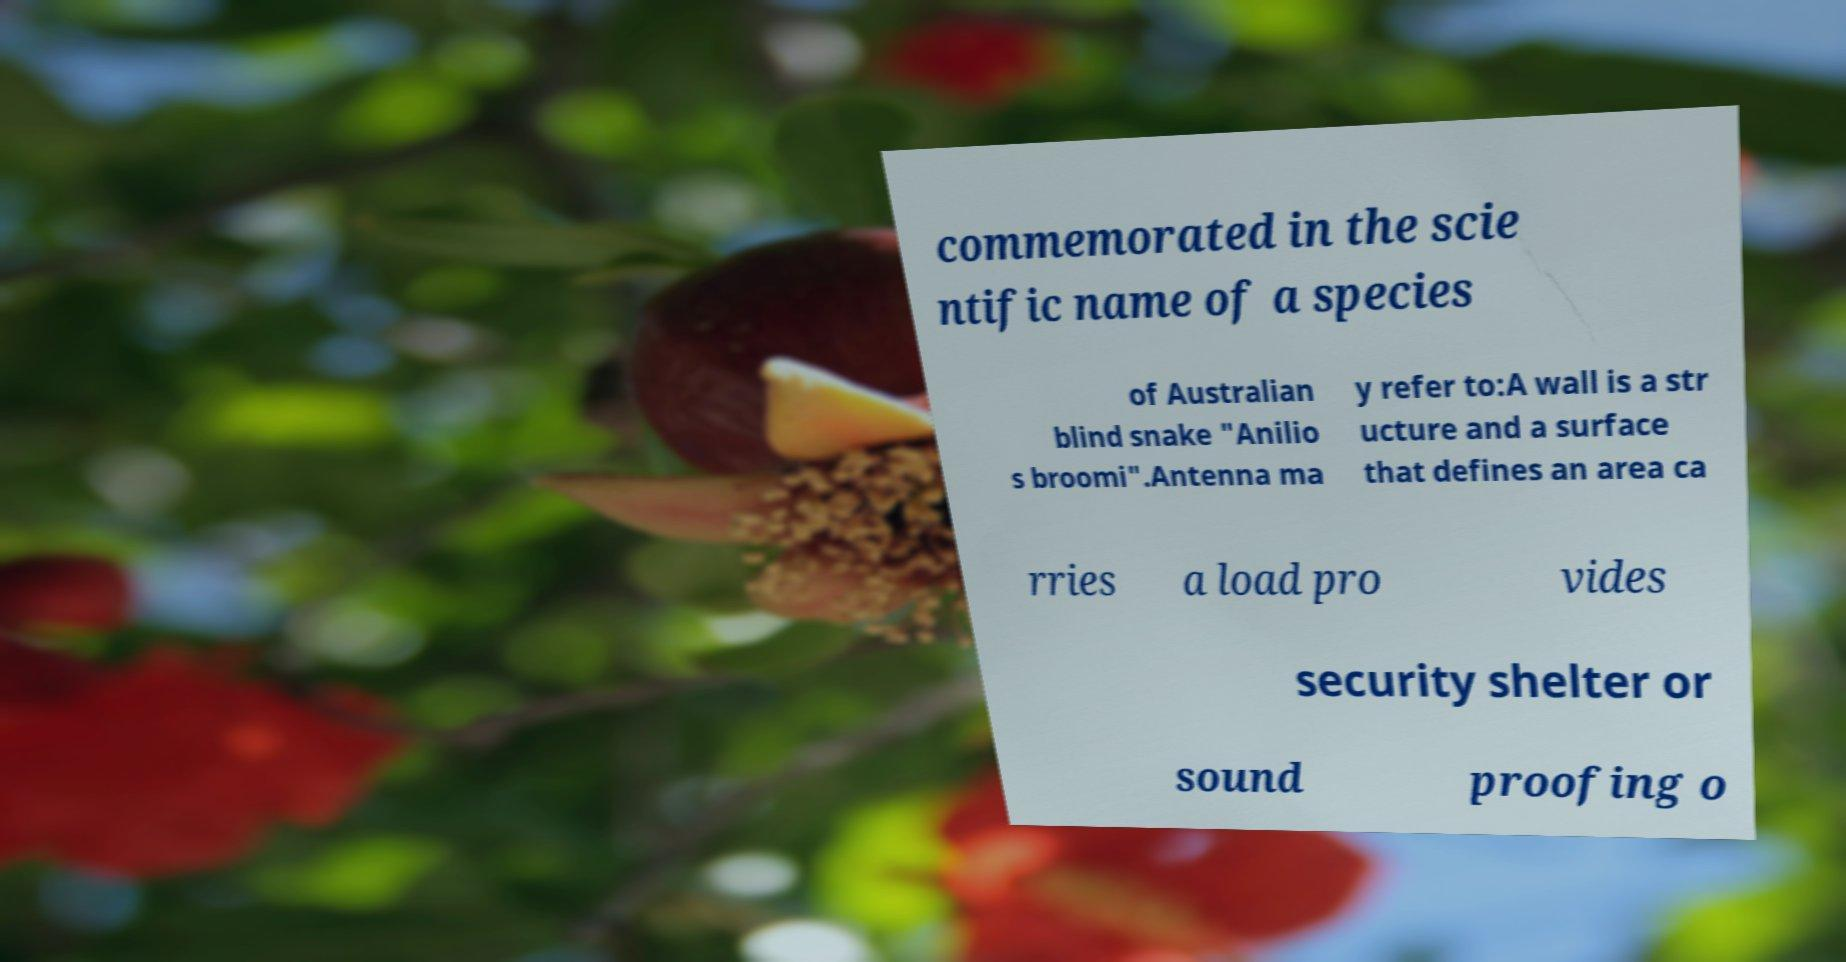What messages or text are displayed in this image? I need them in a readable, typed format. commemorated in the scie ntific name of a species of Australian blind snake "Anilio s broomi".Antenna ma y refer to:A wall is a str ucture and a surface that defines an area ca rries a load pro vides security shelter or sound proofing o 